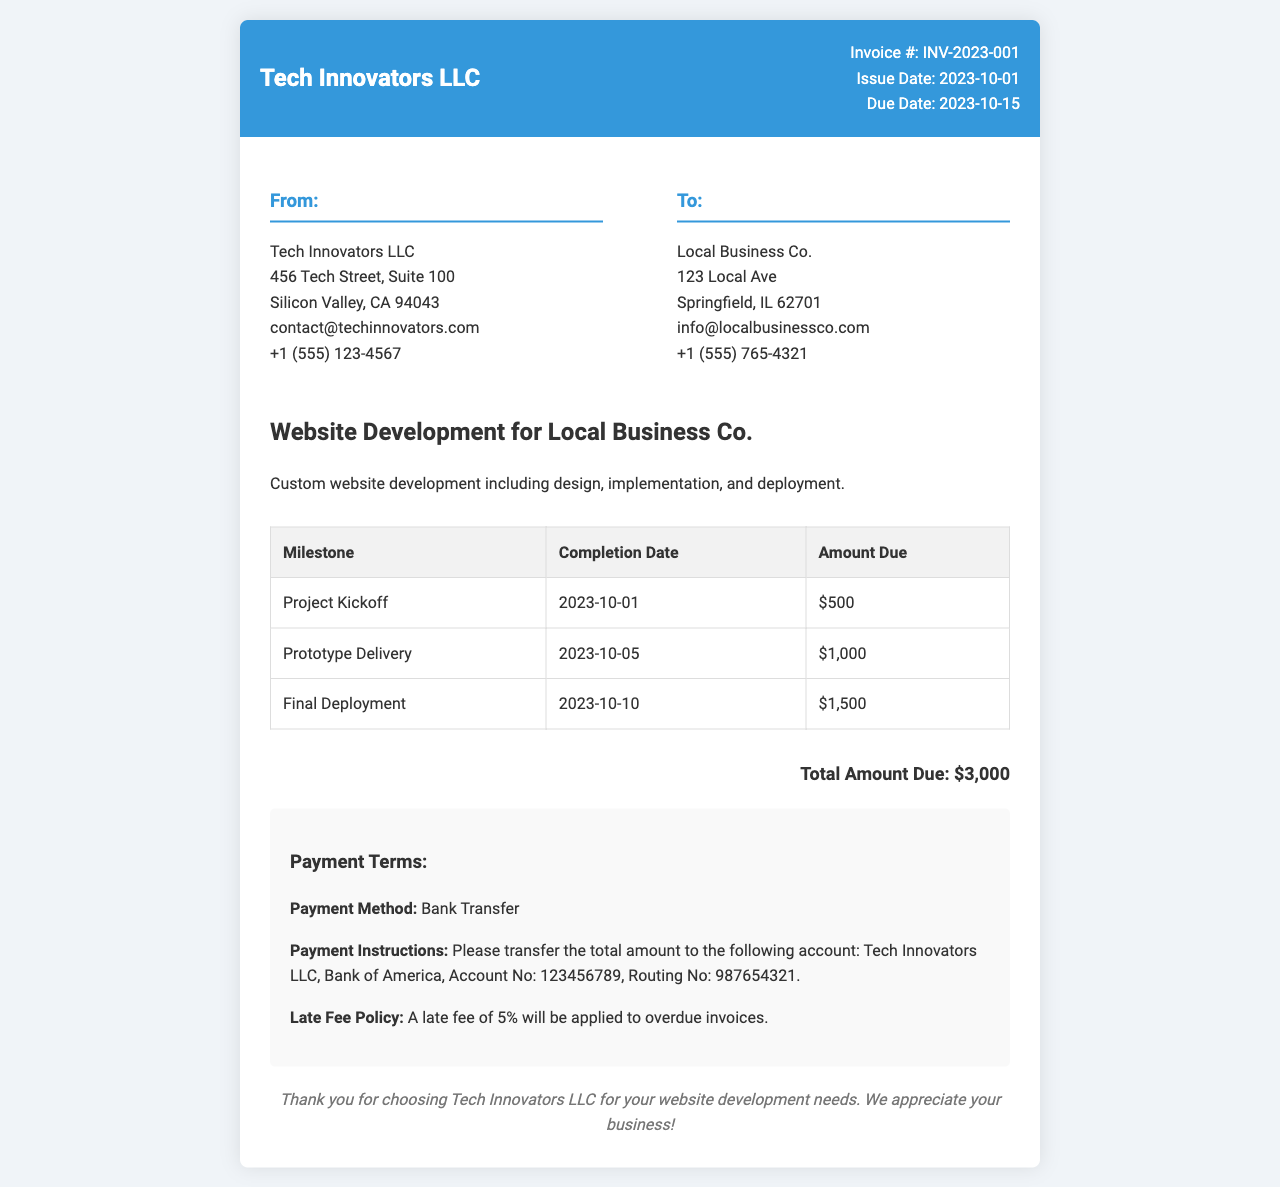What is the invoice number? The invoice number is explicitly stated in the document as "Invoice #: INV-2023-001".
Answer: INV-2023-001 What is the total amount due? The total amount due is clearly listed in the document as "Total Amount Due: $3,000".
Answer: $3,000 What is the completion date for the final deployment milestone? The completion date for the final deployment milestone appears in the table as "2023-10-10".
Answer: 2023-10-10 What payment method is specified? The payment method is stated in the payment terms section as "Bank Transfer".
Answer: Bank Transfer When is the due date for the invoice? The due date is indicated in the document as "Due Date: 2023-10-15".
Answer: 2023-10-15 What is the late fee percentage for overdue invoices? The late fee percentage is mentioned in the document as "5%".
Answer: 5% What company provided the services? The company that provided the services is mentioned as "Tech Innovators LLC".
Answer: Tech Innovators LLC What are payment instructions for the client? The payment instructions are specified as "Please transfer the total amount to the following account".
Answer: Transfer to Tech Innovators LLC Account What was delivered on 2023-10-05? The milestone delivered on this date is listed in the document as "Prototype Delivery".
Answer: Prototype Delivery 